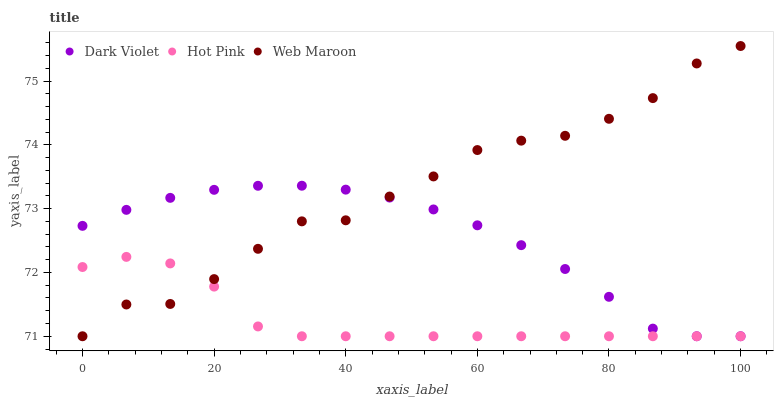Does Hot Pink have the minimum area under the curve?
Answer yes or no. Yes. Does Web Maroon have the maximum area under the curve?
Answer yes or no. Yes. Does Dark Violet have the minimum area under the curve?
Answer yes or no. No. Does Dark Violet have the maximum area under the curve?
Answer yes or no. No. Is Dark Violet the smoothest?
Answer yes or no. Yes. Is Web Maroon the roughest?
Answer yes or no. Yes. Is Web Maroon the smoothest?
Answer yes or no. No. Is Dark Violet the roughest?
Answer yes or no. No. Does Hot Pink have the lowest value?
Answer yes or no. Yes. Does Web Maroon have the highest value?
Answer yes or no. Yes. Does Dark Violet have the highest value?
Answer yes or no. No. Does Web Maroon intersect Hot Pink?
Answer yes or no. Yes. Is Web Maroon less than Hot Pink?
Answer yes or no. No. Is Web Maroon greater than Hot Pink?
Answer yes or no. No. 